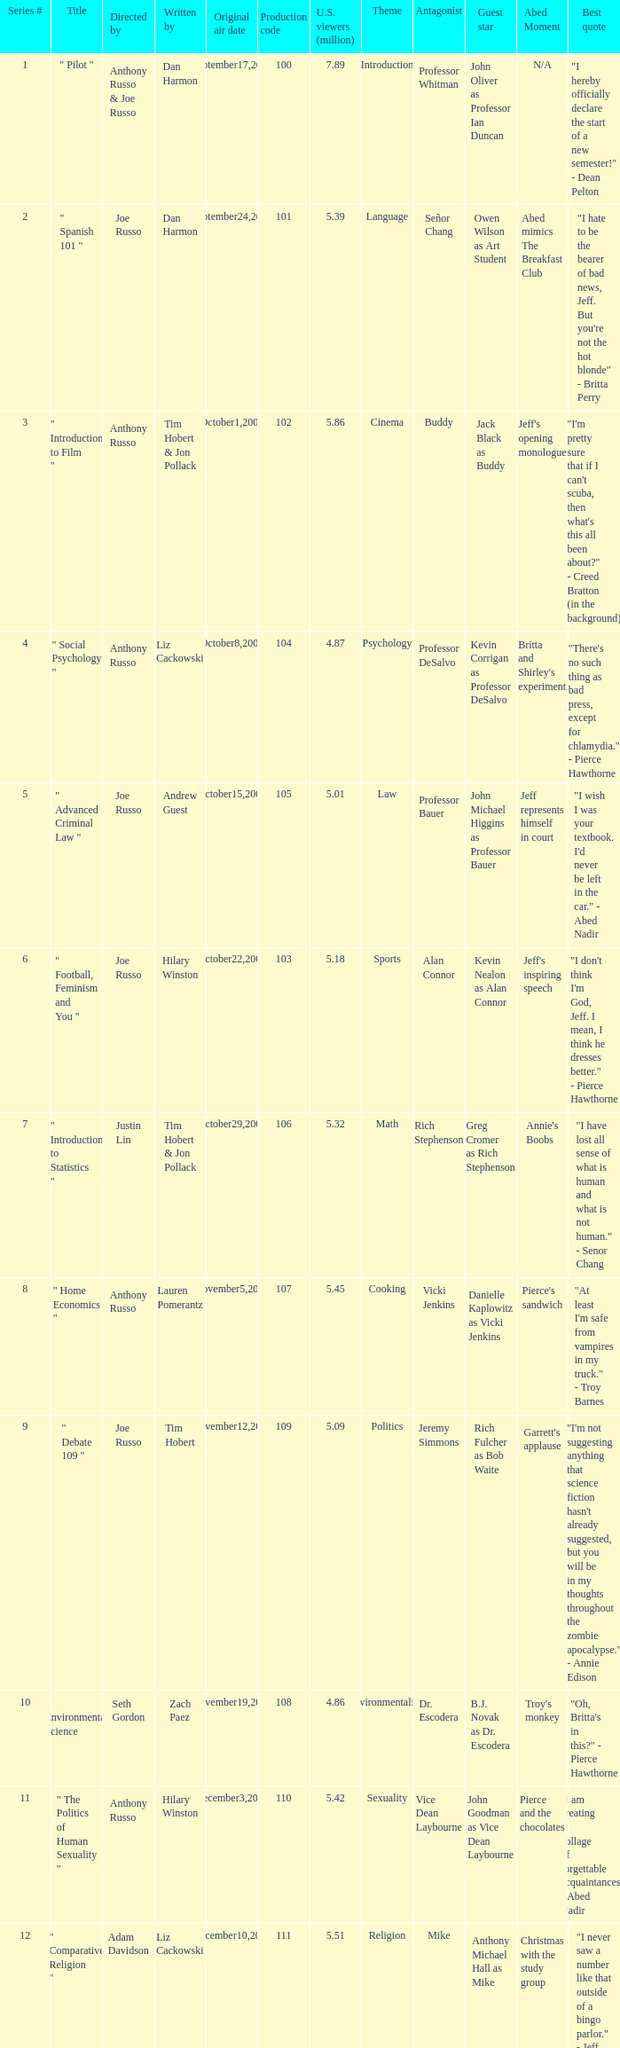What is the title of the series # 8? " Home Economics ". 